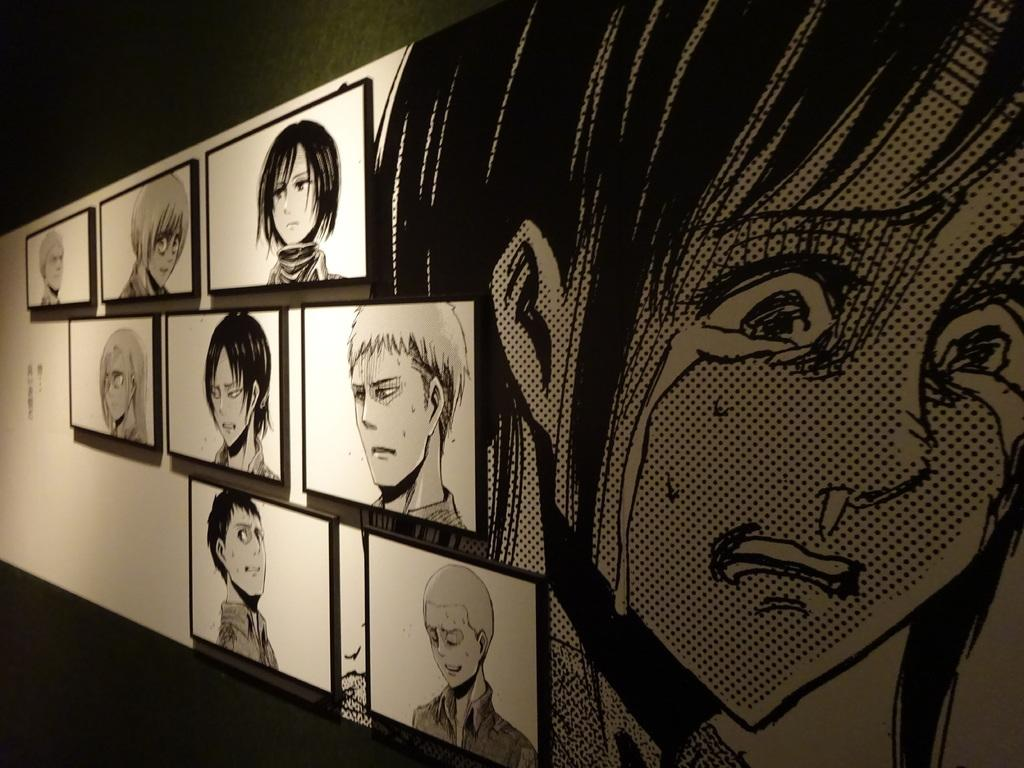What type of images are displayed on the wall in the image? There are pictures of cartoons on the wall in the image. What is the reaction of the cartoon characters to the political situation in the image? There are no cartoon characters present in the image, and therefore no reaction can be observed. 